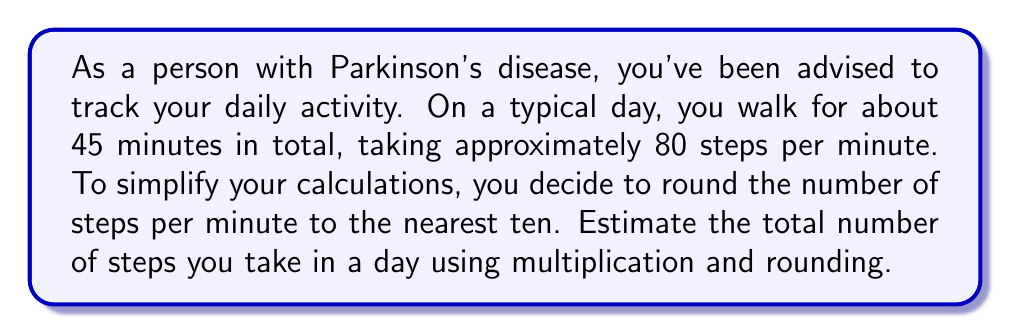Give your solution to this math problem. Let's break this problem down into steps:

1. Round the number of steps per minute:
   $80$ steps per minute rounds to $80$ (nearest ten)

2. Calculate the total number of minutes walked:
   $45$ minutes

3. Set up the multiplication:
   $\text{Estimated steps} = \text{Rounded steps per minute} \times \text{Total minutes walked}$
   
   $\text{Estimated steps} = 80 \times 45$

4. Perform the multiplication:
   $$\begin{aligned}
   80 \times 45 &= 80 \times (40 + 5) \\
   &= (80 \times 40) + (80 \times 5) \\
   &= 3200 + 400 \\
   &= 3600
   \end{aligned}$$

5. Round the final answer to the nearest hundred for a simpler estimate:
   $3600$ rounds to $3600$ (nearest hundred)

Therefore, the estimated number of steps taken in a day is 3600.
Answer: $3600$ steps 